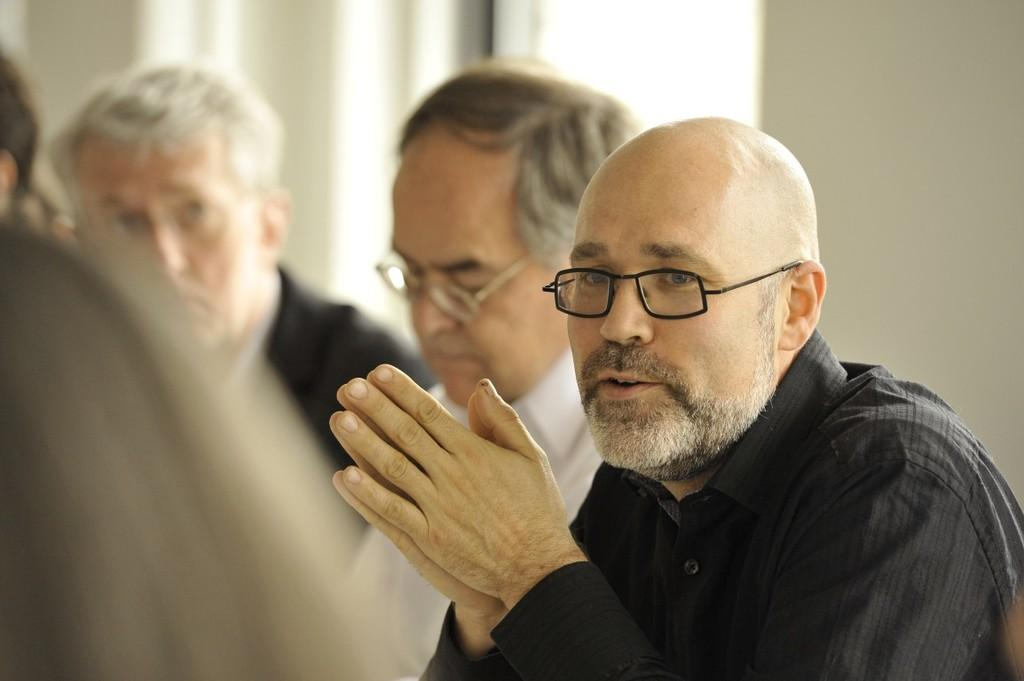How many individuals are present in the image? There is a group of people in the image, but the exact number cannot be determined without more information. What is located behind the group of people? There is a wall visible behind the people. What is the measurement of the island in the image? There is no island present in the image, so it cannot be measured. 